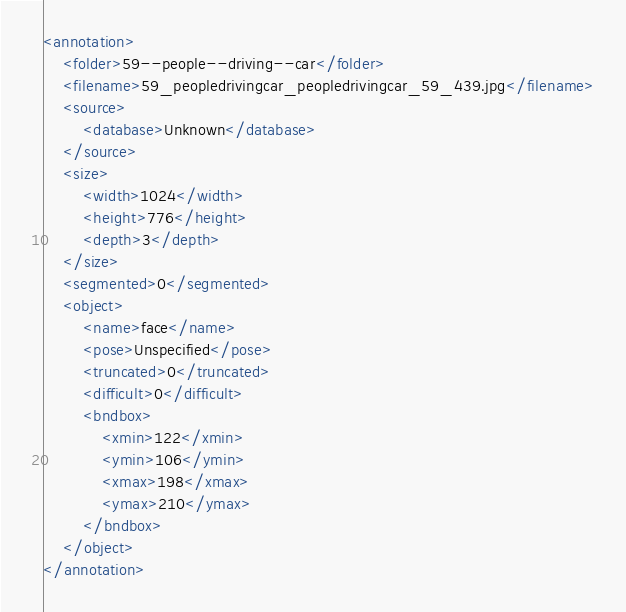Convert code to text. <code><loc_0><loc_0><loc_500><loc_500><_XML_><annotation>
    <folder>59--people--driving--car</folder>
    <filename>59_peopledrivingcar_peopledrivingcar_59_439.jpg</filename>
    <source>
        <database>Unknown</database>
    </source>
    <size>
        <width>1024</width>
        <height>776</height>
        <depth>3</depth>
    </size>
    <segmented>0</segmented>
    <object>
        <name>face</name>
        <pose>Unspecified</pose>
        <truncated>0</truncated>
        <difficult>0</difficult>
        <bndbox>
            <xmin>122</xmin>
            <ymin>106</ymin>
            <xmax>198</xmax>
            <ymax>210</ymax>
        </bndbox>
    </object>
</annotation>
</code> 